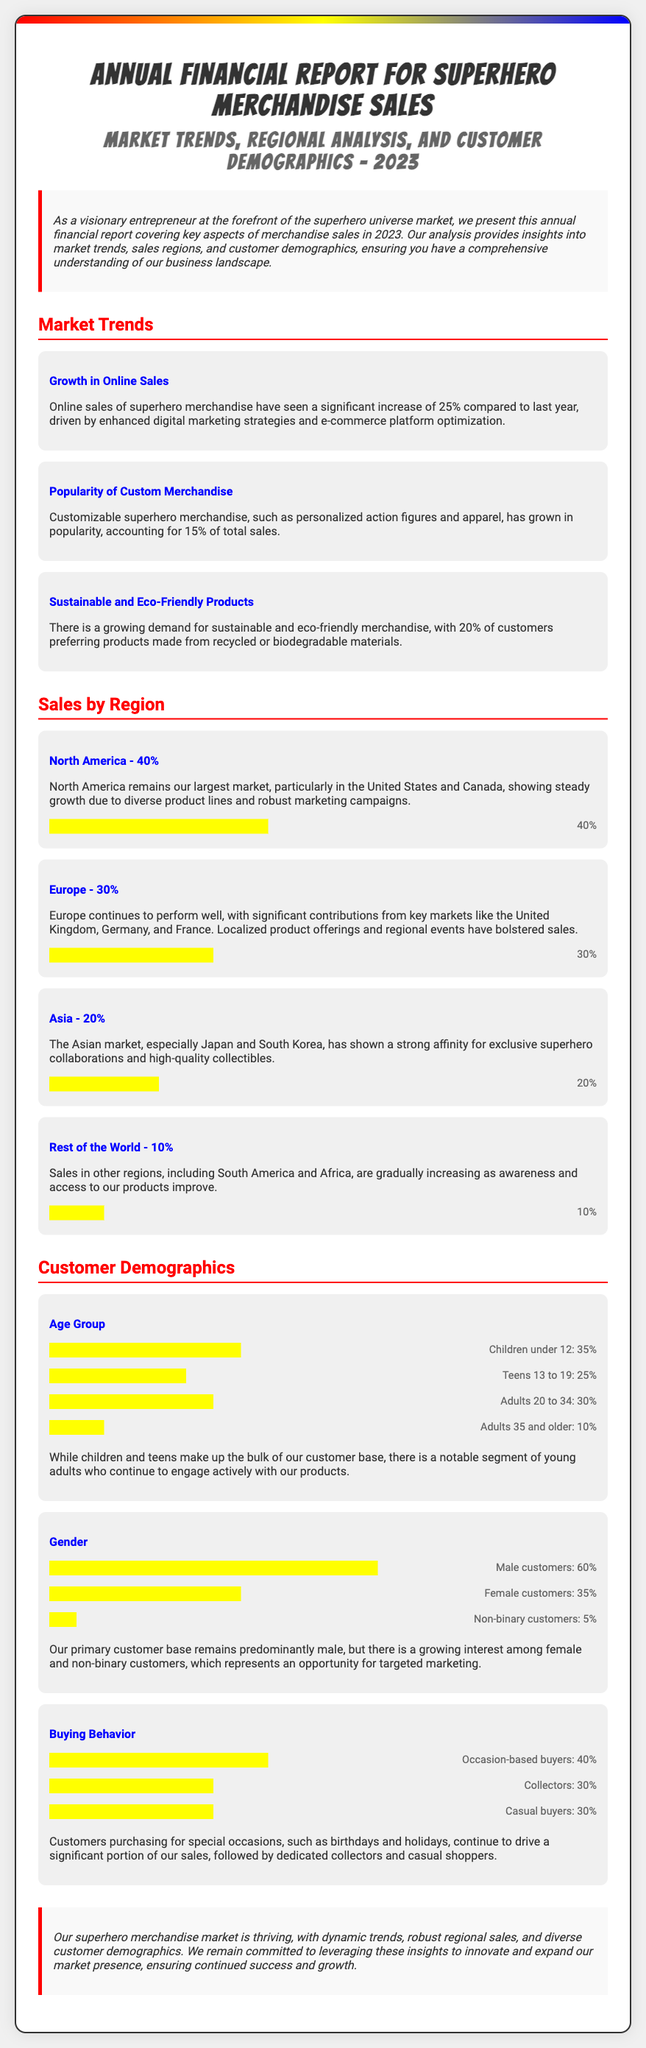what was the increase in online sales compared to last year? The document states that online sales of superhero merchandise have seen a significant increase of 25% compared to last year.
Answer: 25% what percentage of total sales comes from customizable merchandise? The report indicates that customizable superhero merchandise accounts for 15% of total sales.
Answer: 15% which region has the largest market share in sales? According to the document, North America remains our largest market with a share of 40%.
Answer: North America what is the percentage of customers who prefer sustainable products? It is stated that 20% of customers prefer products made from recycled or biodegradable materials.
Answer: 20% what age group constitutes the largest segment of buyers? The largest age group of buyers is "Children under 12," which makes up 35% of the customer base.
Answer: Children under 12 what marketing opportunity is identified for targeting demographics? The document highlights a growing interest among female and non-binary customers as an opportunity for targeted marketing.
Answer: Female and non-binary customers how many customers are collectors according to buying behavior? The report notes that collectors make up 30% of the buying behavior segment.
Answer: 30% what is the share of sales for the rest of the world? The document states that sales in the rest of the world account for 10%.
Answer: 10% what is the conclusion of the report regarding the superhero merchandise market? The report concludes that the superhero merchandise market is thriving, with dynamic trends and diverse demographics.
Answer: Thriving 